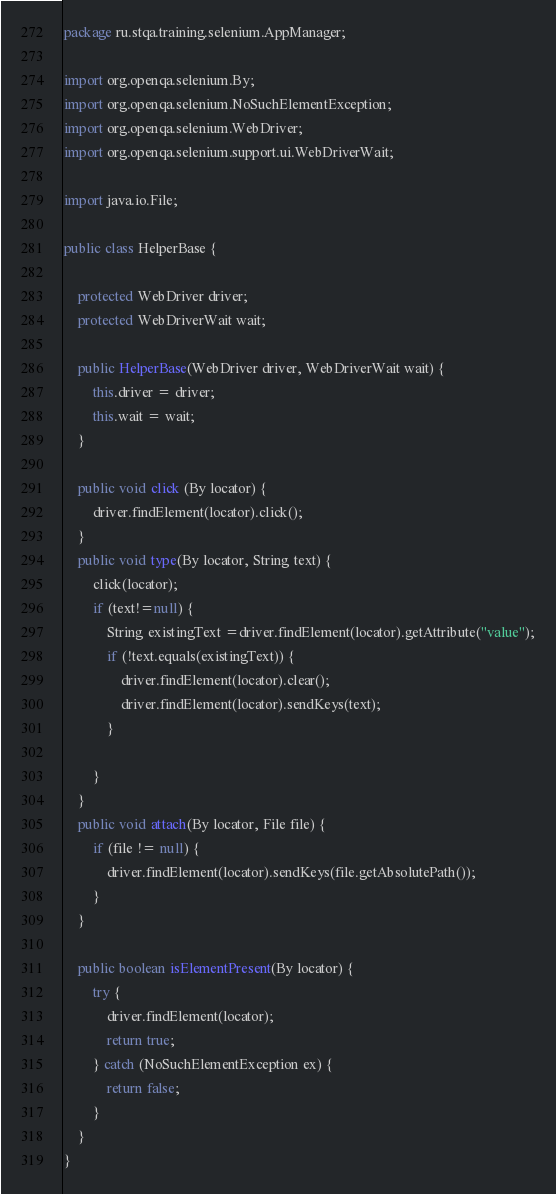<code> <loc_0><loc_0><loc_500><loc_500><_Java_>package ru.stqa.training.selenium.AppManager;

import org.openqa.selenium.By;
import org.openqa.selenium.NoSuchElementException;
import org.openqa.selenium.WebDriver;
import org.openqa.selenium.support.ui.WebDriverWait;

import java.io.File;

public class HelperBase {

    protected WebDriver driver;
    protected WebDriverWait wait;

    public HelperBase(WebDriver driver, WebDriverWait wait) {
        this.driver = driver;
        this.wait = wait;
    }

    public void click (By locator) {
        driver.findElement(locator).click();
    }
    public void type(By locator, String text) {
        click(locator);
        if (text!=null) {
            String existingText =driver.findElement(locator).getAttribute("value");
            if (!text.equals(existingText)) {
                driver.findElement(locator).clear();
                driver.findElement(locator).sendKeys(text);
            }

        }
    }
    public void attach(By locator, File file) {
        if (file != null) {
            driver.findElement(locator).sendKeys(file.getAbsolutePath());
        }
    }

    public boolean isElementPresent(By locator) {
        try {
            driver.findElement(locator);
            return true;
        } catch (NoSuchElementException ex) {
            return false;
        }
    }
}
</code> 